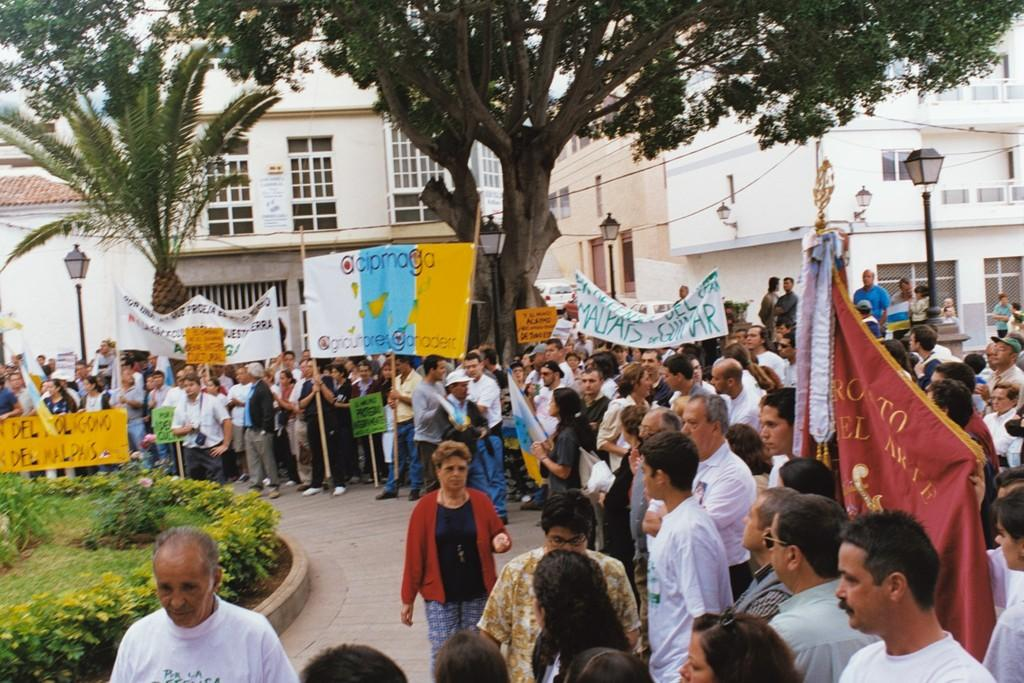What are the people on the road doing in the image? The people on the road are holding banners and placards. What can be seen in the background of the image? There are buildings, trees, and garden plants in the image. What type of lighting is present in the image? There are street lights in the image. What type of game is being played by the children in the image? There are no children present in the image, and therefore no game is being played. What material is the metal used for in the image? There is no mention of metal in the image, so it cannot be determined what material it might be used for. 